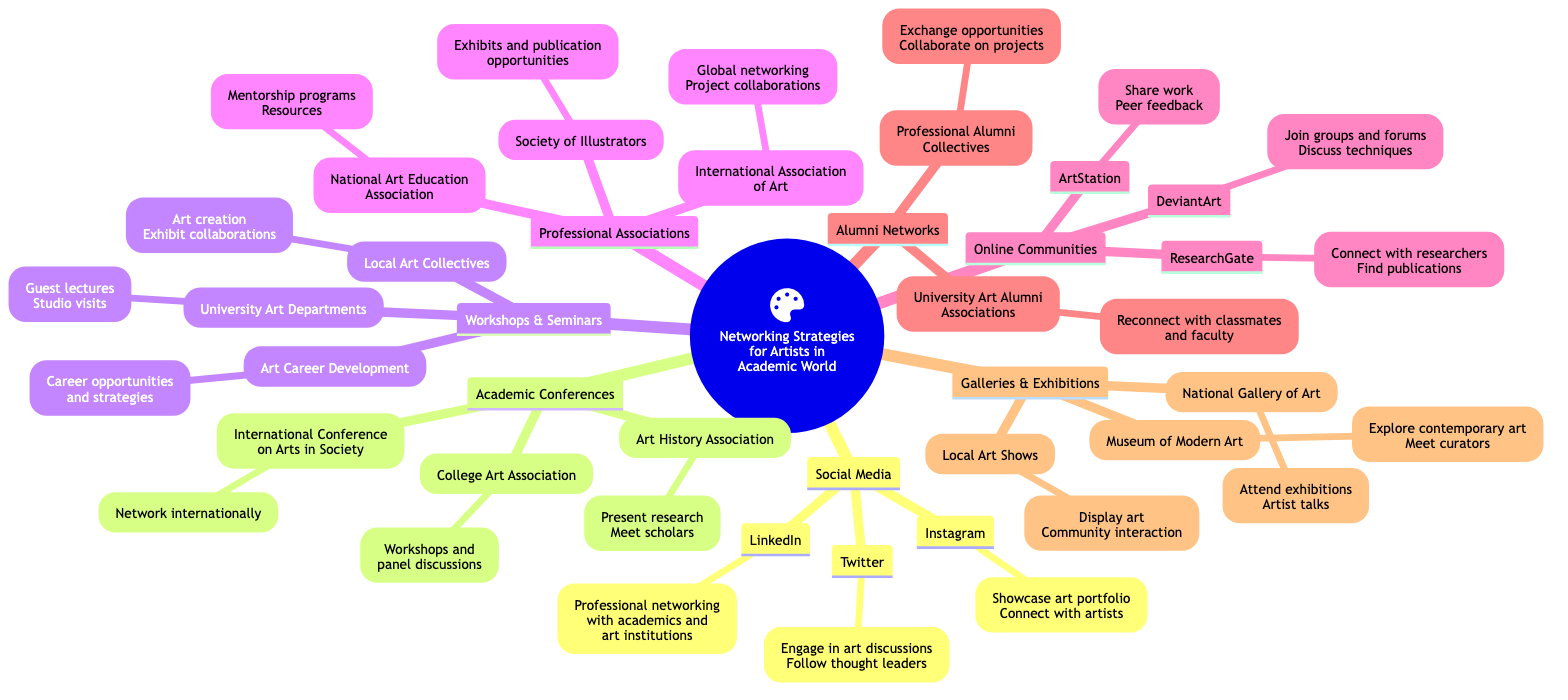What are three platforms listed under Social Media? The diagram shows three platforms under the "Social Media" category: Instagram, LinkedIn, and Twitter. This is a descriptive question focusing on specific nodes.
Answer: Instagram, LinkedIn, Twitter How many types of Networking Strategies are mentioned in the diagram? The main category "Networking Strategies for Artists in the Academic World" branches into seven subcategories: Social Media, Academic Conferences, Workshops & Seminars, Professional Associations, Online Communities, Alumni Networks, and Galleries & Exhibitions. This counts as a counting question.
Answer: Seven What is one benefit of attending the Art History Association conference? The diagram notes that attending the Art History Association allows artists to "Present research" and "Meet scholars." This requires connecting the node with its description to derive its benefit.
Answer: Present research Which Online Community is specifically for sharing work and receiving feedback? The diagram under the "Online Communities" category states that ArtStation is the platform for sharing work and receiving peer feedback. The question seeks a specific node and its associated description.
Answer: ArtStation Which professional association offers mentorship programs? The National Art Education Association, as shown under the "Professional Associations" category, provides access to mentorship programs and resources. This question focuses on identifying the right node related to mentorship.
Answer: National Art Education Association How do Alumni Networks facilitate collaborative opportunities? The "Professional Alumni Collectives" under the "Alumni Networks" category specify that they "Exchange opportunities and collaborate on projects." Therefore, by being part of these networks, artists can leverage their alumni relationships for collaboration. This requires integrating information from both the node and its details.
Answer: Exchange opportunities Which exhibition space is mentioned for attending artist talks? The diagram indicates that the National Gallery of Art provides opportunities to "Attend exhibitions" and "Artist talks." This question focuses on identifying a specific exhibition space related to artist talks.
Answer: National Gallery of Art Name one event where international networking occurs. The diagram highlights the "International Conference on the Arts in Society" as an event focused on networking with international artists and academics, directly indicating an international networking opportunity.
Answer: International Conference on the Arts in Society 